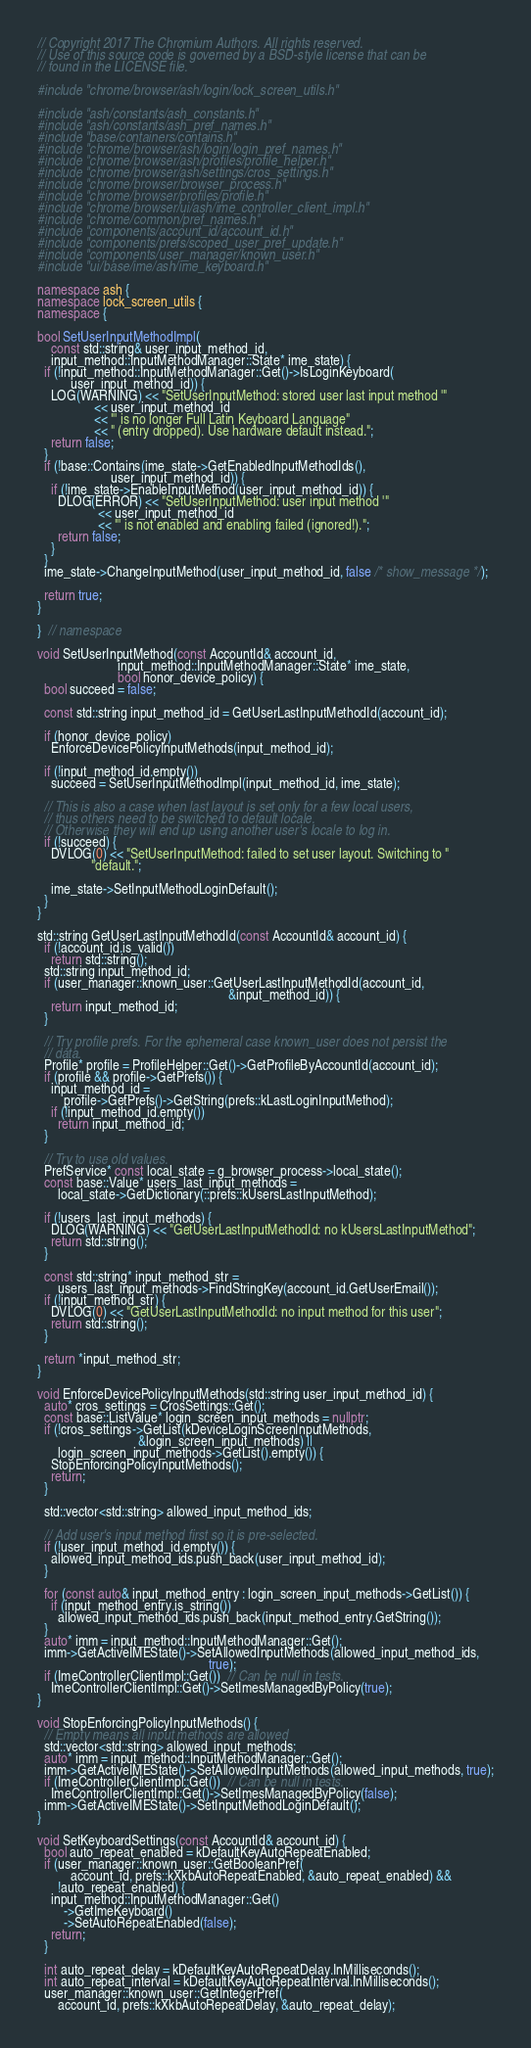Convert code to text. <code><loc_0><loc_0><loc_500><loc_500><_C++_>// Copyright 2017 The Chromium Authors. All rights reserved.
// Use of this source code is governed by a BSD-style license that can be
// found in the LICENSE file.

#include "chrome/browser/ash/login/lock_screen_utils.h"

#include "ash/constants/ash_constants.h"
#include "ash/constants/ash_pref_names.h"
#include "base/containers/contains.h"
#include "chrome/browser/ash/login/login_pref_names.h"
#include "chrome/browser/ash/profiles/profile_helper.h"
#include "chrome/browser/ash/settings/cros_settings.h"
#include "chrome/browser/browser_process.h"
#include "chrome/browser/profiles/profile.h"
#include "chrome/browser/ui/ash/ime_controller_client_impl.h"
#include "chrome/common/pref_names.h"
#include "components/account_id/account_id.h"
#include "components/prefs/scoped_user_pref_update.h"
#include "components/user_manager/known_user.h"
#include "ui/base/ime/ash/ime_keyboard.h"

namespace ash {
namespace lock_screen_utils {
namespace {

bool SetUserInputMethodImpl(
    const std::string& user_input_method_id,
    input_method::InputMethodManager::State* ime_state) {
  if (!input_method::InputMethodManager::Get()->IsLoginKeyboard(
          user_input_method_id)) {
    LOG(WARNING) << "SetUserInputMethod: stored user last input method '"
                 << user_input_method_id
                 << "' is no longer Full Latin Keyboard Language"
                 << " (entry dropped). Use hardware default instead.";
    return false;
  }
  if (!base::Contains(ime_state->GetEnabledInputMethodIds(),
                      user_input_method_id)) {
    if (!ime_state->EnableInputMethod(user_input_method_id)) {
      DLOG(ERROR) << "SetUserInputMethod: user input method '"
                  << user_input_method_id
                  << "' is not enabled and enabling failed (ignored!).";
      return false;
    }
  }
  ime_state->ChangeInputMethod(user_input_method_id, false /* show_message */);

  return true;
}

}  // namespace

void SetUserInputMethod(const AccountId& account_id,
                        input_method::InputMethodManager::State* ime_state,
                        bool honor_device_policy) {
  bool succeed = false;

  const std::string input_method_id = GetUserLastInputMethodId(account_id);

  if (honor_device_policy)
    EnforceDevicePolicyInputMethods(input_method_id);

  if (!input_method_id.empty())
    succeed = SetUserInputMethodImpl(input_method_id, ime_state);

  // This is also a case when last layout is set only for a few local users,
  // thus others need to be switched to default locale.
  // Otherwise they will end up using another user's locale to log in.
  if (!succeed) {
    DVLOG(0) << "SetUserInputMethod: failed to set user layout. Switching to "
                "default.";

    ime_state->SetInputMethodLoginDefault();
  }
}

std::string GetUserLastInputMethodId(const AccountId& account_id) {
  if (!account_id.is_valid())
    return std::string();
  std::string input_method_id;
  if (user_manager::known_user::GetUserLastInputMethodId(account_id,
                                                         &input_method_id)) {
    return input_method_id;
  }

  // Try profile prefs. For the ephemeral case known_user does not persist the
  // data.
  Profile* profile = ProfileHelper::Get()->GetProfileByAccountId(account_id);
  if (profile && profile->GetPrefs()) {
    input_method_id =
        profile->GetPrefs()->GetString(prefs::kLastLoginInputMethod);
    if (!input_method_id.empty())
      return input_method_id;
  }

  // Try to use old values.
  PrefService* const local_state = g_browser_process->local_state();
  const base::Value* users_last_input_methods =
      local_state->GetDictionary(::prefs::kUsersLastInputMethod);

  if (!users_last_input_methods) {
    DLOG(WARNING) << "GetUserLastInputMethodId: no kUsersLastInputMethod";
    return std::string();
  }

  const std::string* input_method_str =
      users_last_input_methods->FindStringKey(account_id.GetUserEmail());
  if (!input_method_str) {
    DVLOG(0) << "GetUserLastInputMethodId: no input method for this user";
    return std::string();
  }

  return *input_method_str;
}

void EnforceDevicePolicyInputMethods(std::string user_input_method_id) {
  auto* cros_settings = CrosSettings::Get();
  const base::ListValue* login_screen_input_methods = nullptr;
  if (!cros_settings->GetList(kDeviceLoginScreenInputMethods,
                              &login_screen_input_methods) ||
      login_screen_input_methods->GetList().empty()) {
    StopEnforcingPolicyInputMethods();
    return;
  }

  std::vector<std::string> allowed_input_method_ids;

  // Add user's input method first so it is pre-selected.
  if (!user_input_method_id.empty()) {
    allowed_input_method_ids.push_back(user_input_method_id);
  }

  for (const auto& input_method_entry : login_screen_input_methods->GetList()) {
    if (input_method_entry.is_string())
      allowed_input_method_ids.push_back(input_method_entry.GetString());
  }
  auto* imm = input_method::InputMethodManager::Get();
  imm->GetActiveIMEState()->SetAllowedInputMethods(allowed_input_method_ids,
                                                   true);
  if (ImeControllerClientImpl::Get())  // Can be null in tests.
    ImeControllerClientImpl::Get()->SetImesManagedByPolicy(true);
}

void StopEnforcingPolicyInputMethods() {
  // Empty means all input methods are allowed
  std::vector<std::string> allowed_input_methods;
  auto* imm = input_method::InputMethodManager::Get();
  imm->GetActiveIMEState()->SetAllowedInputMethods(allowed_input_methods, true);
  if (ImeControllerClientImpl::Get())  // Can be null in tests.
    ImeControllerClientImpl::Get()->SetImesManagedByPolicy(false);
  imm->GetActiveIMEState()->SetInputMethodLoginDefault();
}

void SetKeyboardSettings(const AccountId& account_id) {
  bool auto_repeat_enabled = kDefaultKeyAutoRepeatEnabled;
  if (user_manager::known_user::GetBooleanPref(
          account_id, prefs::kXkbAutoRepeatEnabled, &auto_repeat_enabled) &&
      !auto_repeat_enabled) {
    input_method::InputMethodManager::Get()
        ->GetImeKeyboard()
        ->SetAutoRepeatEnabled(false);
    return;
  }

  int auto_repeat_delay = kDefaultKeyAutoRepeatDelay.InMilliseconds();
  int auto_repeat_interval = kDefaultKeyAutoRepeatInterval.InMilliseconds();
  user_manager::known_user::GetIntegerPref(
      account_id, prefs::kXkbAutoRepeatDelay, &auto_repeat_delay);</code> 